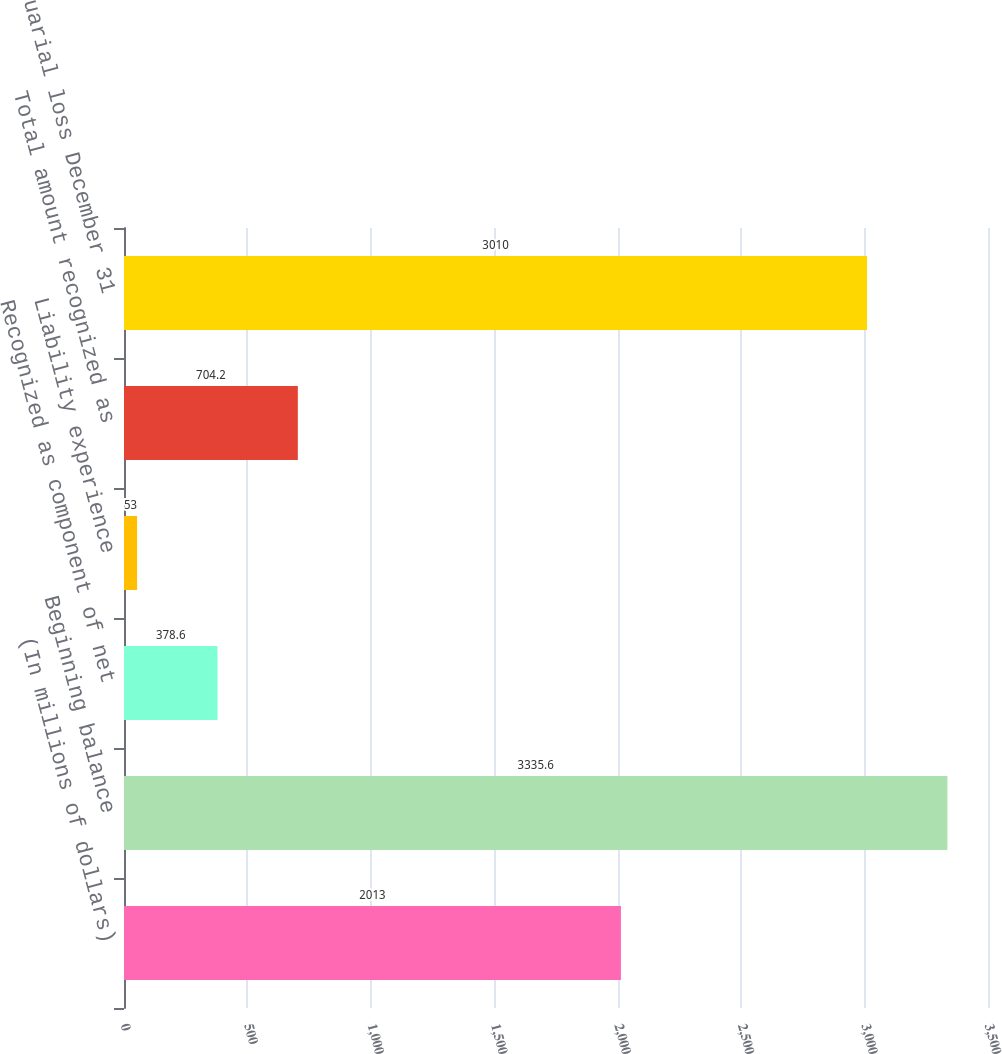Convert chart. <chart><loc_0><loc_0><loc_500><loc_500><bar_chart><fcel>(In millions of dollars)<fcel>Beginning balance<fcel>Recognized as component of net<fcel>Liability experience<fcel>Total amount recognized as<fcel>Net actuarial loss December 31<nl><fcel>2013<fcel>3335.6<fcel>378.6<fcel>53<fcel>704.2<fcel>3010<nl></chart> 